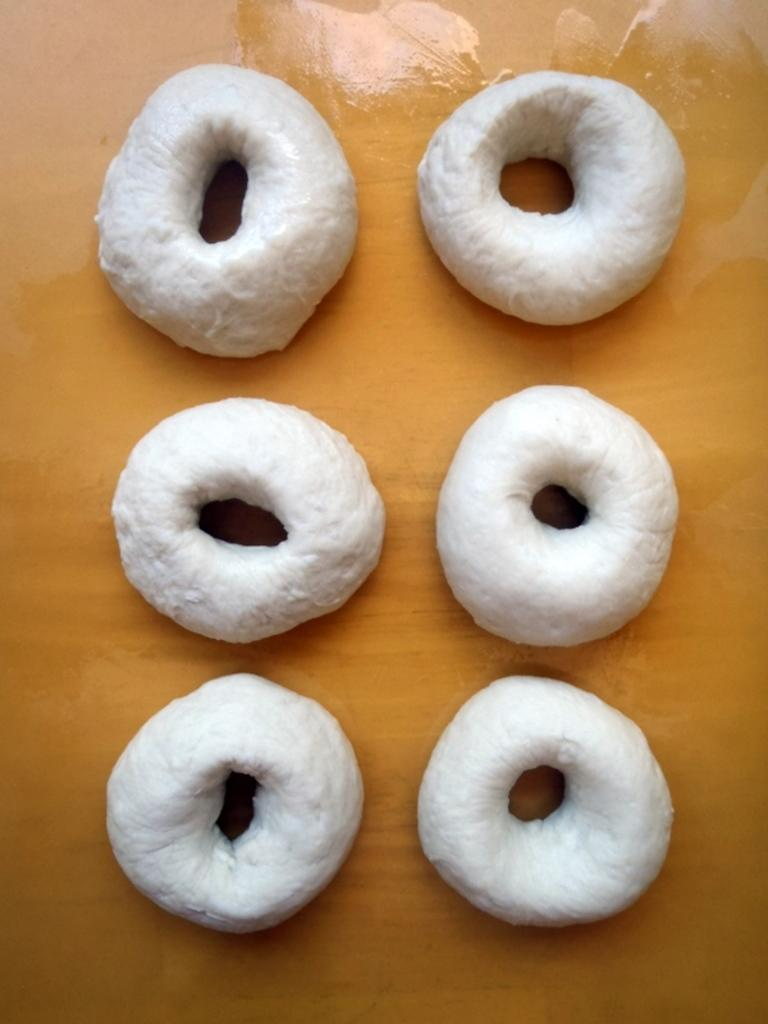What type of food is present on the table in the image? There are unbaked doughnuts in the image. Where are the unbaked doughnuts located? The unbaked doughnuts are present on a table. What offer does the father make in the image? There is no reference to an offer or a father in the image, so it is not possible to answer that question. 